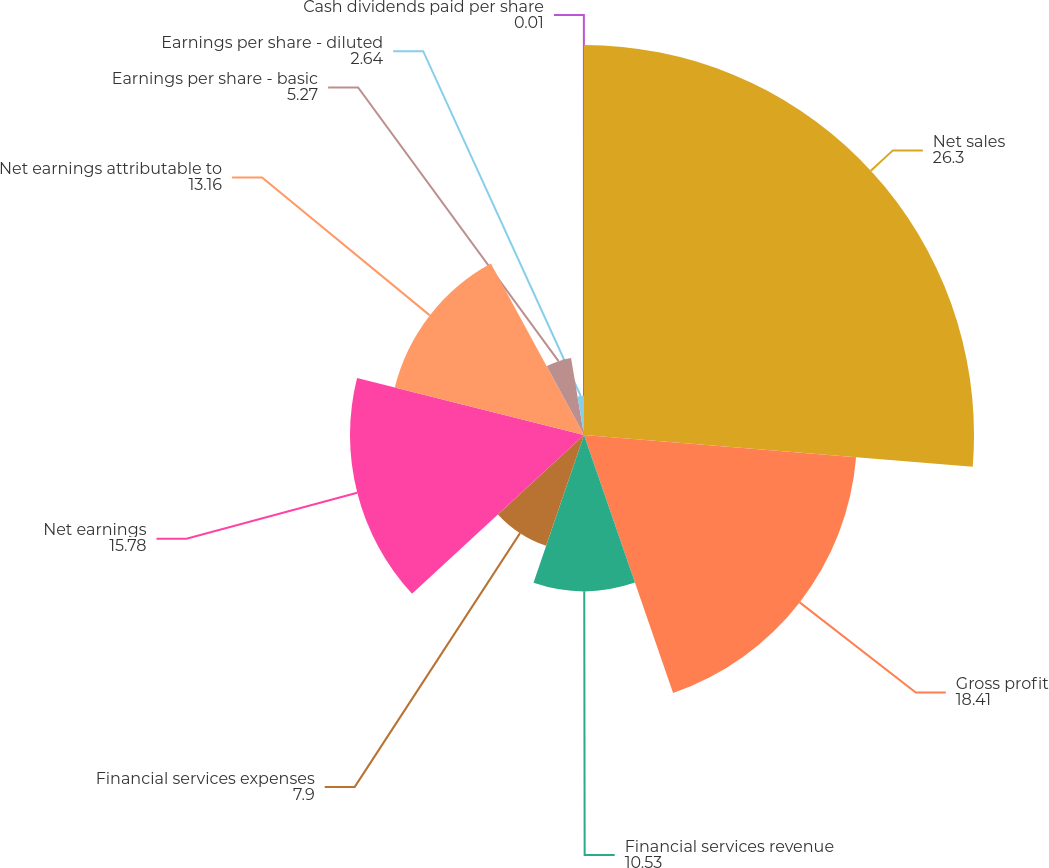Convert chart to OTSL. <chart><loc_0><loc_0><loc_500><loc_500><pie_chart><fcel>Net sales<fcel>Gross profit<fcel>Financial services revenue<fcel>Financial services expenses<fcel>Net earnings<fcel>Net earnings attributable to<fcel>Earnings per share - basic<fcel>Earnings per share - diluted<fcel>Cash dividends paid per share<nl><fcel>26.3%<fcel>18.41%<fcel>10.53%<fcel>7.9%<fcel>15.78%<fcel>13.16%<fcel>5.27%<fcel>2.64%<fcel>0.01%<nl></chart> 